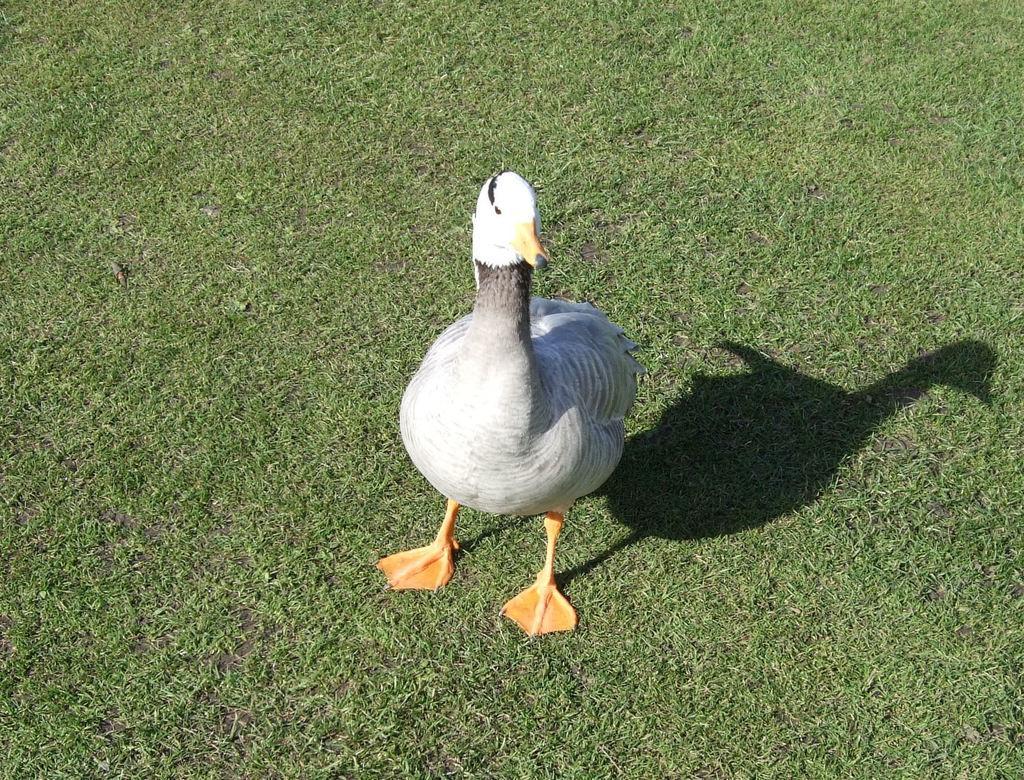In one or two sentences, can you explain what this image depicts? In this picture we can see the white color duck, standing on the grass ground. 